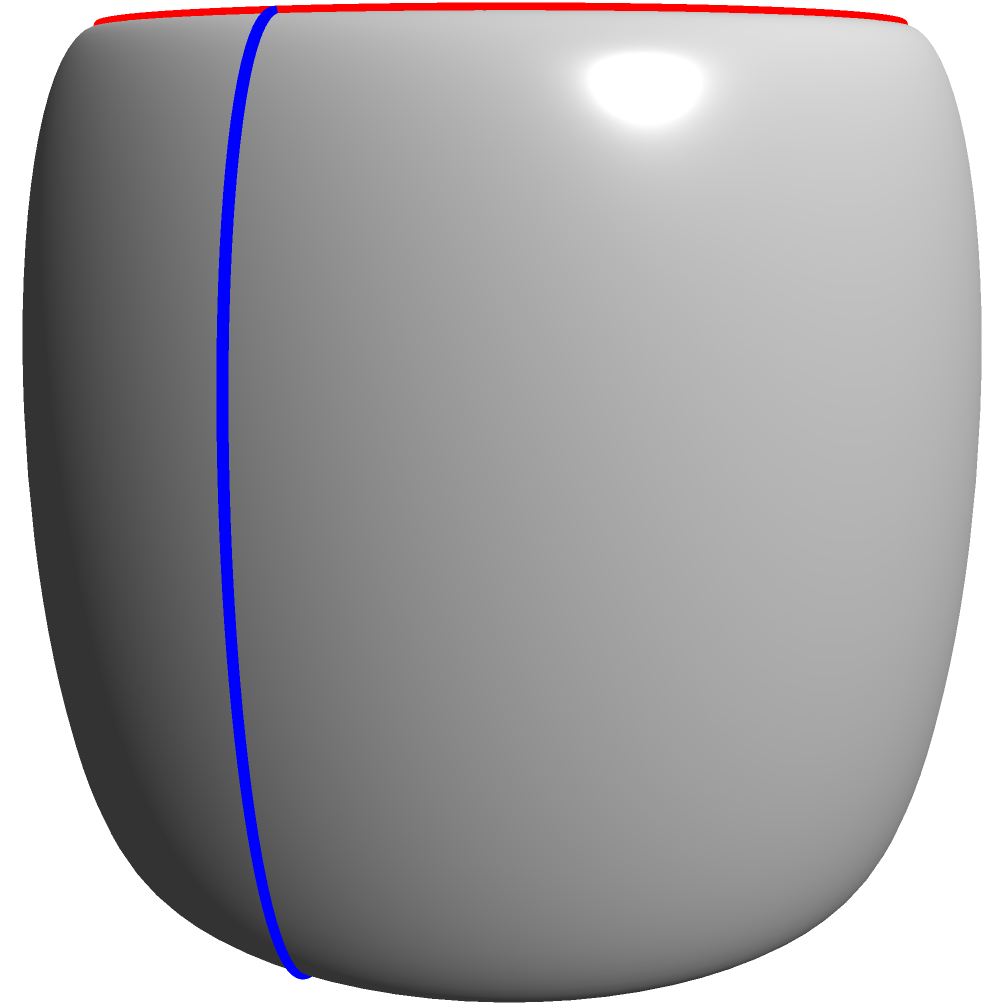Consider a torus-shaped speaker design, as shown in the diagram. The red loop represents a path around the major circumference of the torus, while the blue loop represents a meridian path. If you were to design a vinyl record label inspired by this speaker, which topological property would be most relevant to incorporate into your design to reflect the torus shape? To answer this question, let's consider the topological properties of a torus:

1. A torus is a surface of genus 1, meaning it has one "hole".

2. The torus has two fundamental cycles that cannot be continuously deformed into each other:
   a) The red loop, which goes around the major circumference (longitudinal direction).
   b) The blue loop, which goes around the minor circumference (meridional direction).

3. These two cycles are non-contractible, meaning they cannot be shrunk to a point on the surface.

4. The torus is orientable, meaning it has a consistent normal direction at every point.

5. One of the most distinctive topological properties of a torus is its Euler characteristic, $\chi$.

6. The Euler characteristic is calculated using the formula: $\chi = V - E + F$, where V is the number of vertices, E is the number of edges, and F is the number of faces in a polygonal decomposition of the surface.

7. For a torus, the Euler characteristic is always 0: $\chi_{torus} = 0$

8. This is different from other surfaces like a sphere ($\chi_{sphere} = 2$) or a projective plane ($\chi_{projective plane} = 1$).

9. The Euler characteristic of 0 is directly related to the genus (number of holes) of the torus, through the relation: $\chi = 2 - 2g$, where g is the genus.

Given the persona of a vinyl collector and artist, incorporating the Euler characteristic of 0 into the label design would be most relevant. This property uniquely identifies the topology of the torus and could be creatively represented in the design, perhaps through patterns or symmetries that reflect this mathematical concept.
Answer: Euler characteristic of 0 